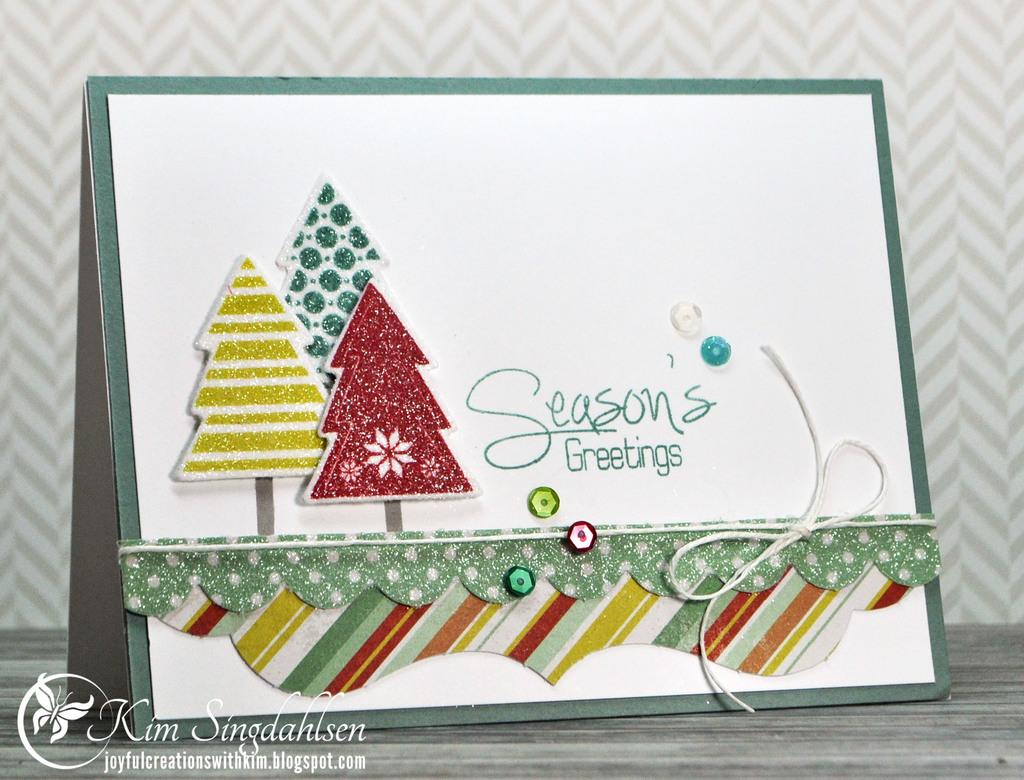What is the main subject in the middle of the image? There is a greeting card in the middle of the image. How is the greeting card decorated? The greeting card is decorated. What can be found at the bottom of the image? There is text at the bottom of the image. What part of the room is visible in the image? The floor is visible in the image. What can be seen in the background of the image? There is a wall in the background of the image. What type of treatment is the person receiving in the image? There is no person present in the image, and therefore no treatment can be observed. What color is the thread used to decorate the greeting card? The provided facts do not mention the color of any thread used to decorate the greeting card. 